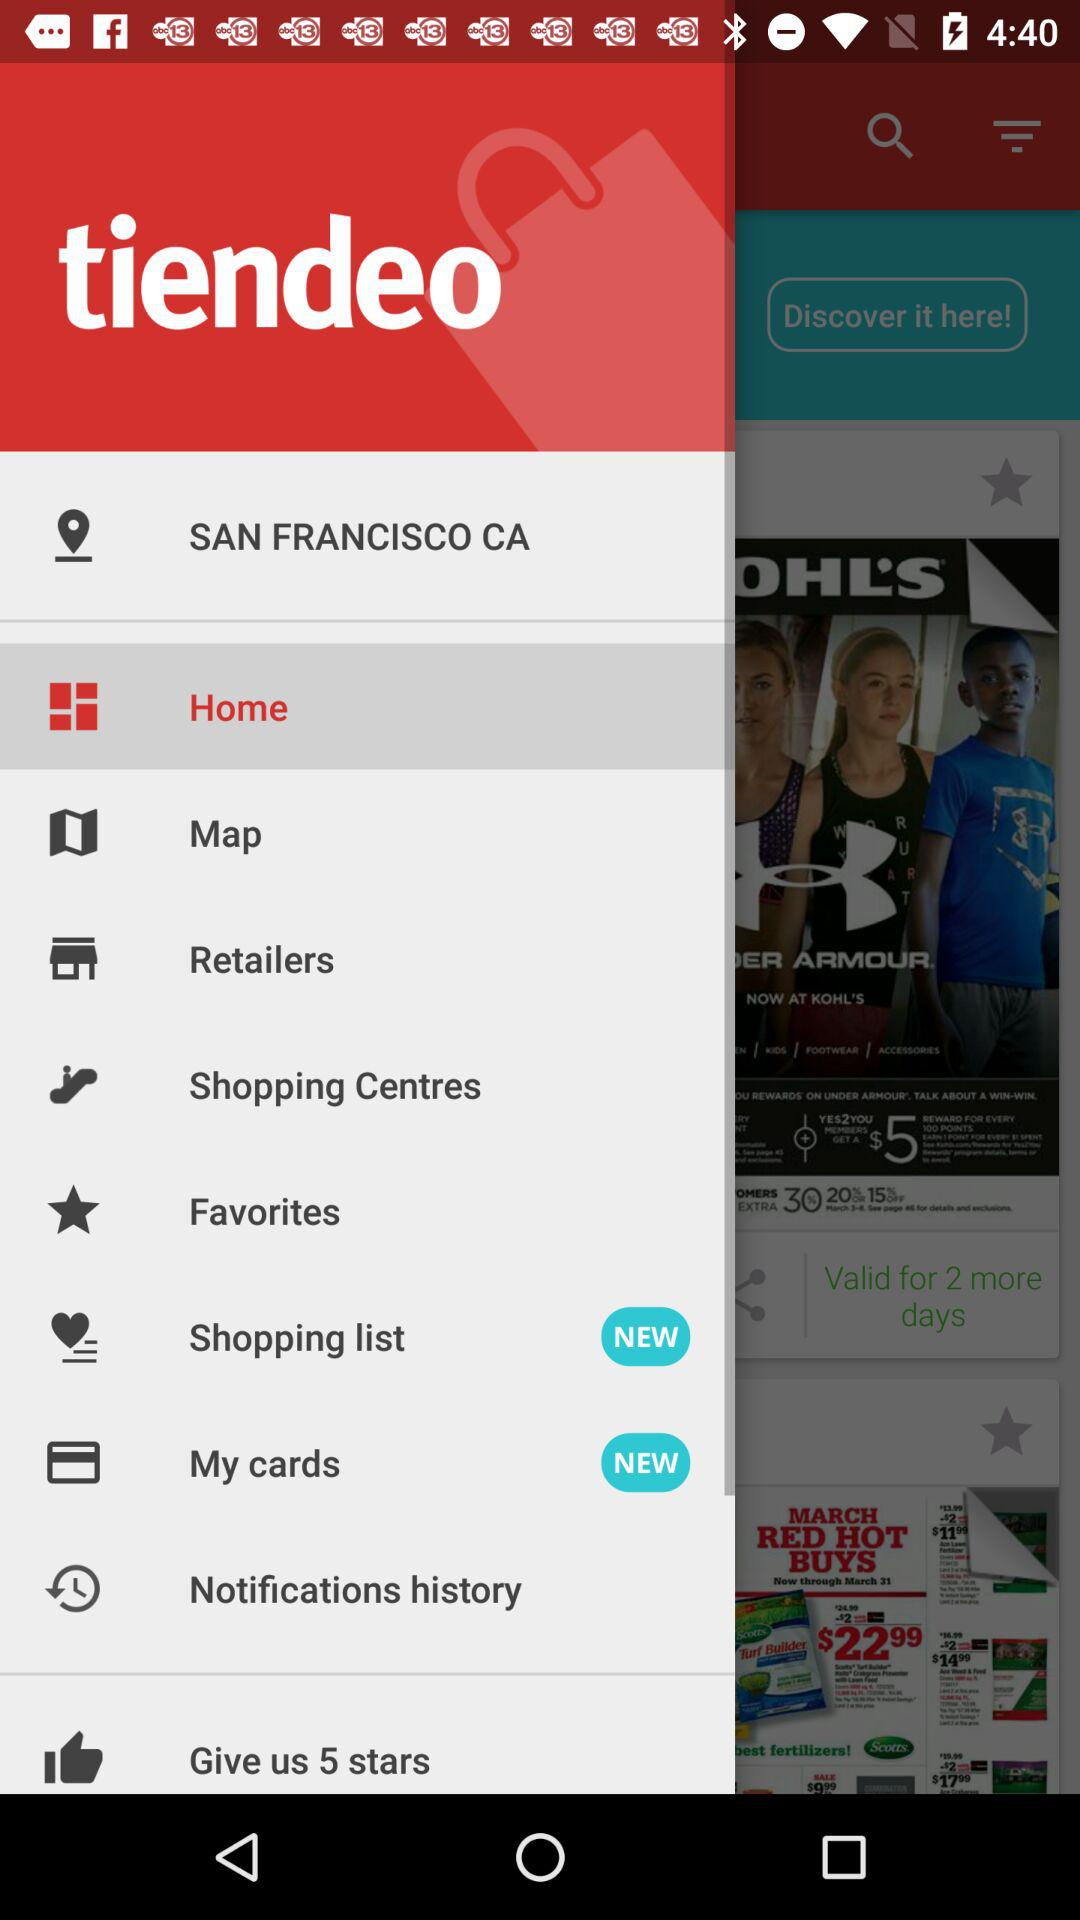Which item is selected? The selected item is "Home". 